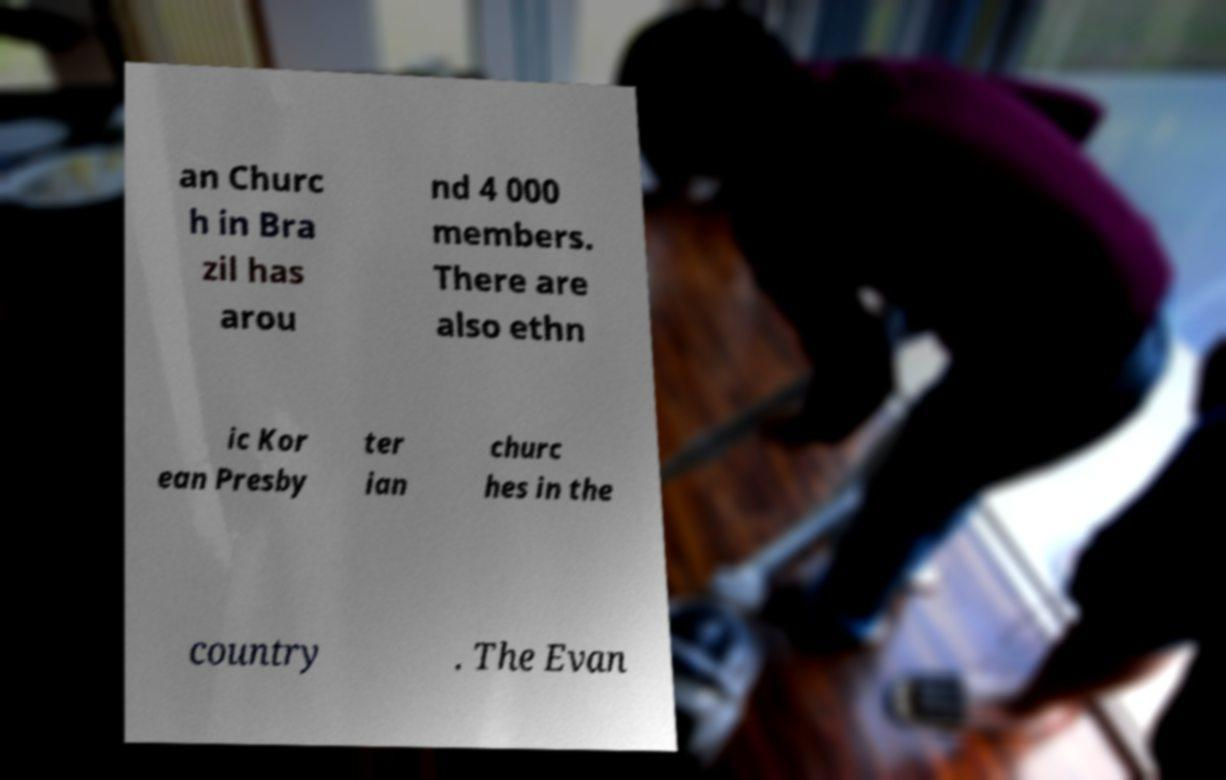Can you read and provide the text displayed in the image?This photo seems to have some interesting text. Can you extract and type it out for me? an Churc h in Bra zil has arou nd 4 000 members. There are also ethn ic Kor ean Presby ter ian churc hes in the country . The Evan 